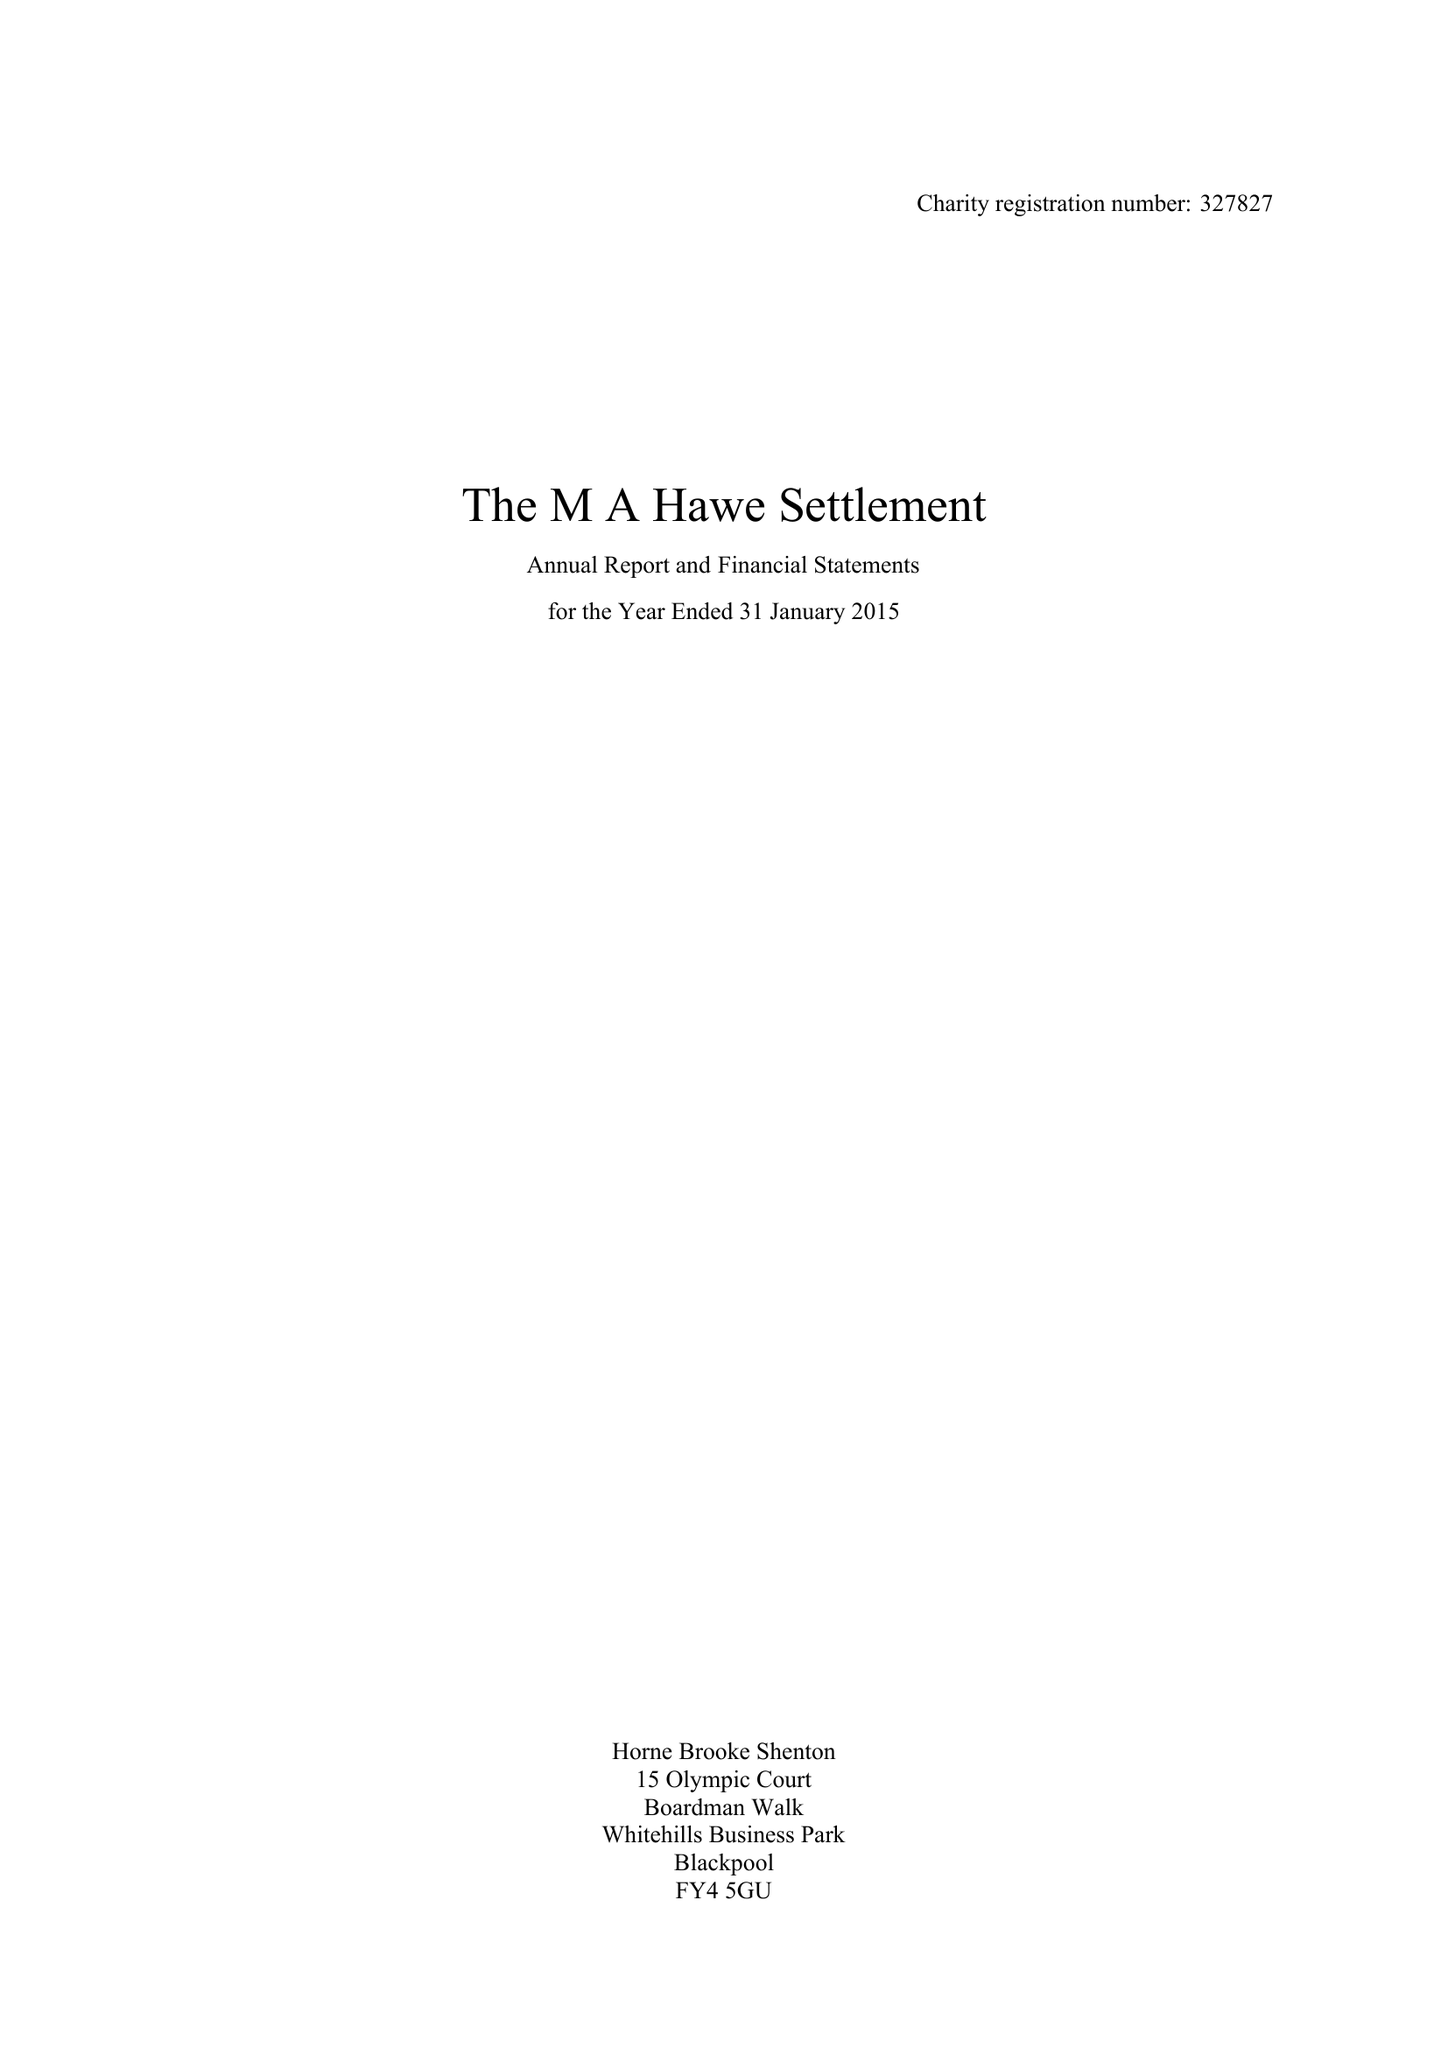What is the value for the charity_name?
Answer the question using a single word or phrase. The Ma Hawe Settlement 